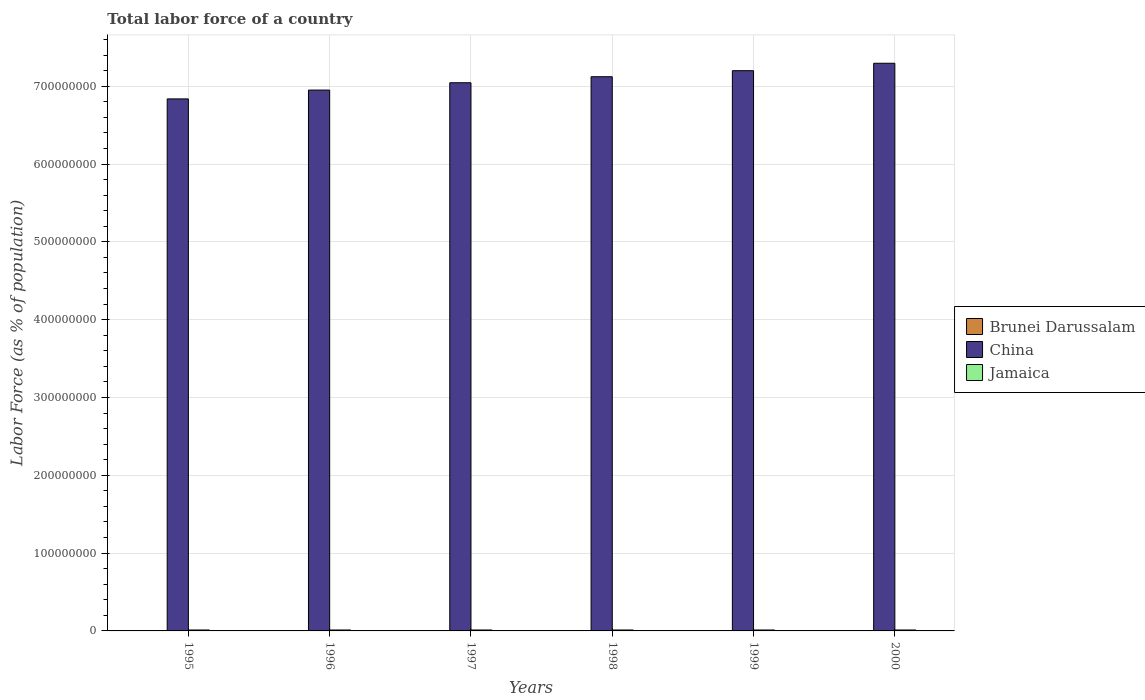How many different coloured bars are there?
Provide a succinct answer. 3. How many groups of bars are there?
Keep it short and to the point. 6. Are the number of bars per tick equal to the number of legend labels?
Give a very brief answer. Yes. What is the label of the 2nd group of bars from the left?
Make the answer very short. 1996. What is the percentage of labor force in Brunei Darussalam in 1998?
Provide a succinct answer. 1.45e+05. Across all years, what is the maximum percentage of labor force in Brunei Darussalam?
Offer a terse response. 1.55e+05. Across all years, what is the minimum percentage of labor force in Brunei Darussalam?
Offer a terse response. 1.31e+05. In which year was the percentage of labor force in Brunei Darussalam maximum?
Ensure brevity in your answer.  2000. In which year was the percentage of labor force in China minimum?
Your answer should be very brief. 1995. What is the total percentage of labor force in Jamaica in the graph?
Your response must be concise. 7.18e+06. What is the difference between the percentage of labor force in Jamaica in 1996 and that in 1997?
Your answer should be compact. 5620. What is the difference between the percentage of labor force in China in 1999 and the percentage of labor force in Brunei Darussalam in 1996?
Provide a short and direct response. 7.20e+08. What is the average percentage of labor force in Brunei Darussalam per year?
Ensure brevity in your answer.  1.43e+05. In the year 1995, what is the difference between the percentage of labor force in Jamaica and percentage of labor force in China?
Keep it short and to the point. -6.82e+08. What is the ratio of the percentage of labor force in Jamaica in 1995 to that in 1996?
Your response must be concise. 1. Is the percentage of labor force in Jamaica in 1995 less than that in 1996?
Make the answer very short. Yes. Is the difference between the percentage of labor force in Jamaica in 1997 and 2000 greater than the difference between the percentage of labor force in China in 1997 and 2000?
Offer a very short reply. Yes. What is the difference between the highest and the second highest percentage of labor force in China?
Make the answer very short. 9.53e+06. What is the difference between the highest and the lowest percentage of labor force in China?
Offer a very short reply. 4.58e+07. What does the 1st bar from the left in 1995 represents?
Provide a succinct answer. Brunei Darussalam. What does the 3rd bar from the right in 1997 represents?
Your answer should be very brief. Brunei Darussalam. How many bars are there?
Offer a very short reply. 18. What is the difference between two consecutive major ticks on the Y-axis?
Offer a very short reply. 1.00e+08. What is the title of the graph?
Give a very brief answer. Total labor force of a country. What is the label or title of the Y-axis?
Your answer should be compact. Labor Force (as % of population). What is the Labor Force (as % of population) of Brunei Darussalam in 1995?
Your answer should be compact. 1.31e+05. What is the Labor Force (as % of population) in China in 1995?
Your answer should be very brief. 6.84e+08. What is the Labor Force (as % of population) in Jamaica in 1995?
Offer a terse response. 1.20e+06. What is the Labor Force (as % of population) of Brunei Darussalam in 1996?
Provide a short and direct response. 1.36e+05. What is the Labor Force (as % of population) in China in 1996?
Provide a short and direct response. 6.95e+08. What is the Labor Force (as % of population) of Jamaica in 1996?
Provide a short and direct response. 1.20e+06. What is the Labor Force (as % of population) of Brunei Darussalam in 1997?
Give a very brief answer. 1.41e+05. What is the Labor Force (as % of population) of China in 1997?
Keep it short and to the point. 7.04e+08. What is the Labor Force (as % of population) of Jamaica in 1997?
Ensure brevity in your answer.  1.20e+06. What is the Labor Force (as % of population) in Brunei Darussalam in 1998?
Give a very brief answer. 1.45e+05. What is the Labor Force (as % of population) in China in 1998?
Keep it short and to the point. 7.12e+08. What is the Labor Force (as % of population) in Jamaica in 1998?
Offer a terse response. 1.19e+06. What is the Labor Force (as % of population) of Brunei Darussalam in 1999?
Make the answer very short. 1.51e+05. What is the Labor Force (as % of population) of China in 1999?
Offer a terse response. 7.20e+08. What is the Labor Force (as % of population) of Jamaica in 1999?
Your answer should be compact. 1.19e+06. What is the Labor Force (as % of population) in Brunei Darussalam in 2000?
Your response must be concise. 1.55e+05. What is the Labor Force (as % of population) of China in 2000?
Provide a succinct answer. 7.29e+08. What is the Labor Force (as % of population) in Jamaica in 2000?
Make the answer very short. 1.19e+06. Across all years, what is the maximum Labor Force (as % of population) of Brunei Darussalam?
Provide a short and direct response. 1.55e+05. Across all years, what is the maximum Labor Force (as % of population) in China?
Your response must be concise. 7.29e+08. Across all years, what is the maximum Labor Force (as % of population) of Jamaica?
Offer a very short reply. 1.20e+06. Across all years, what is the minimum Labor Force (as % of population) of Brunei Darussalam?
Offer a terse response. 1.31e+05. Across all years, what is the minimum Labor Force (as % of population) of China?
Provide a short and direct response. 6.84e+08. Across all years, what is the minimum Labor Force (as % of population) of Jamaica?
Make the answer very short. 1.19e+06. What is the total Labor Force (as % of population) in Brunei Darussalam in the graph?
Ensure brevity in your answer.  8.59e+05. What is the total Labor Force (as % of population) in China in the graph?
Ensure brevity in your answer.  4.24e+09. What is the total Labor Force (as % of population) in Jamaica in the graph?
Keep it short and to the point. 7.18e+06. What is the difference between the Labor Force (as % of population) in Brunei Darussalam in 1995 and that in 1996?
Your answer should be compact. -4586. What is the difference between the Labor Force (as % of population) in China in 1995 and that in 1996?
Give a very brief answer. -1.13e+07. What is the difference between the Labor Force (as % of population) of Jamaica in 1995 and that in 1996?
Make the answer very short. -999. What is the difference between the Labor Force (as % of population) of Brunei Darussalam in 1995 and that in 1997?
Offer a terse response. -9384. What is the difference between the Labor Force (as % of population) of China in 1995 and that in 1997?
Provide a succinct answer. -2.08e+07. What is the difference between the Labor Force (as % of population) of Jamaica in 1995 and that in 1997?
Ensure brevity in your answer.  4621. What is the difference between the Labor Force (as % of population) in Brunei Darussalam in 1995 and that in 1998?
Keep it short and to the point. -1.43e+04. What is the difference between the Labor Force (as % of population) of China in 1995 and that in 1998?
Make the answer very short. -2.85e+07. What is the difference between the Labor Force (as % of population) in Jamaica in 1995 and that in 1998?
Keep it short and to the point. 1.14e+04. What is the difference between the Labor Force (as % of population) in Brunei Darussalam in 1995 and that in 1999?
Your response must be concise. -1.94e+04. What is the difference between the Labor Force (as % of population) of China in 1995 and that in 1999?
Ensure brevity in your answer.  -3.63e+07. What is the difference between the Labor Force (as % of population) in Jamaica in 1995 and that in 1999?
Ensure brevity in your answer.  8970. What is the difference between the Labor Force (as % of population) of Brunei Darussalam in 1995 and that in 2000?
Ensure brevity in your answer.  -2.44e+04. What is the difference between the Labor Force (as % of population) in China in 1995 and that in 2000?
Provide a short and direct response. -4.58e+07. What is the difference between the Labor Force (as % of population) of Jamaica in 1995 and that in 2000?
Give a very brief answer. 7658. What is the difference between the Labor Force (as % of population) of Brunei Darussalam in 1996 and that in 1997?
Your answer should be very brief. -4798. What is the difference between the Labor Force (as % of population) of China in 1996 and that in 1997?
Offer a very short reply. -9.41e+06. What is the difference between the Labor Force (as % of population) in Jamaica in 1996 and that in 1997?
Keep it short and to the point. 5620. What is the difference between the Labor Force (as % of population) of Brunei Darussalam in 1996 and that in 1998?
Your answer should be very brief. -9750. What is the difference between the Labor Force (as % of population) of China in 1996 and that in 1998?
Ensure brevity in your answer.  -1.71e+07. What is the difference between the Labor Force (as % of population) in Jamaica in 1996 and that in 1998?
Your answer should be compact. 1.24e+04. What is the difference between the Labor Force (as % of population) of Brunei Darussalam in 1996 and that in 1999?
Offer a very short reply. -1.48e+04. What is the difference between the Labor Force (as % of population) in China in 1996 and that in 1999?
Provide a succinct answer. -2.49e+07. What is the difference between the Labor Force (as % of population) of Jamaica in 1996 and that in 1999?
Your response must be concise. 9969. What is the difference between the Labor Force (as % of population) of Brunei Darussalam in 1996 and that in 2000?
Your response must be concise. -1.98e+04. What is the difference between the Labor Force (as % of population) in China in 1996 and that in 2000?
Make the answer very short. -3.45e+07. What is the difference between the Labor Force (as % of population) in Jamaica in 1996 and that in 2000?
Keep it short and to the point. 8657. What is the difference between the Labor Force (as % of population) in Brunei Darussalam in 1997 and that in 1998?
Give a very brief answer. -4952. What is the difference between the Labor Force (as % of population) of China in 1997 and that in 1998?
Your response must be concise. -7.73e+06. What is the difference between the Labor Force (as % of population) in Jamaica in 1997 and that in 1998?
Offer a terse response. 6774. What is the difference between the Labor Force (as % of population) in Brunei Darussalam in 1997 and that in 1999?
Offer a terse response. -1.00e+04. What is the difference between the Labor Force (as % of population) in China in 1997 and that in 1999?
Keep it short and to the point. -1.55e+07. What is the difference between the Labor Force (as % of population) of Jamaica in 1997 and that in 1999?
Provide a succinct answer. 4349. What is the difference between the Labor Force (as % of population) in Brunei Darussalam in 1997 and that in 2000?
Give a very brief answer. -1.50e+04. What is the difference between the Labor Force (as % of population) of China in 1997 and that in 2000?
Offer a very short reply. -2.50e+07. What is the difference between the Labor Force (as % of population) of Jamaica in 1997 and that in 2000?
Keep it short and to the point. 3037. What is the difference between the Labor Force (as % of population) in Brunei Darussalam in 1998 and that in 1999?
Provide a succinct answer. -5076. What is the difference between the Labor Force (as % of population) in China in 1998 and that in 1999?
Give a very brief answer. -7.78e+06. What is the difference between the Labor Force (as % of population) of Jamaica in 1998 and that in 1999?
Give a very brief answer. -2425. What is the difference between the Labor Force (as % of population) in Brunei Darussalam in 1998 and that in 2000?
Give a very brief answer. -1.00e+04. What is the difference between the Labor Force (as % of population) in China in 1998 and that in 2000?
Your answer should be compact. -1.73e+07. What is the difference between the Labor Force (as % of population) of Jamaica in 1998 and that in 2000?
Offer a terse response. -3737. What is the difference between the Labor Force (as % of population) of Brunei Darussalam in 1999 and that in 2000?
Keep it short and to the point. -4948. What is the difference between the Labor Force (as % of population) of China in 1999 and that in 2000?
Provide a short and direct response. -9.53e+06. What is the difference between the Labor Force (as % of population) of Jamaica in 1999 and that in 2000?
Provide a succinct answer. -1312. What is the difference between the Labor Force (as % of population) in Brunei Darussalam in 1995 and the Labor Force (as % of population) in China in 1996?
Your answer should be compact. -6.95e+08. What is the difference between the Labor Force (as % of population) in Brunei Darussalam in 1995 and the Labor Force (as % of population) in Jamaica in 1996?
Your response must be concise. -1.07e+06. What is the difference between the Labor Force (as % of population) in China in 1995 and the Labor Force (as % of population) in Jamaica in 1996?
Your response must be concise. 6.82e+08. What is the difference between the Labor Force (as % of population) of Brunei Darussalam in 1995 and the Labor Force (as % of population) of China in 1997?
Your response must be concise. -7.04e+08. What is the difference between the Labor Force (as % of population) in Brunei Darussalam in 1995 and the Labor Force (as % of population) in Jamaica in 1997?
Your answer should be very brief. -1.07e+06. What is the difference between the Labor Force (as % of population) of China in 1995 and the Labor Force (as % of population) of Jamaica in 1997?
Provide a succinct answer. 6.82e+08. What is the difference between the Labor Force (as % of population) in Brunei Darussalam in 1995 and the Labor Force (as % of population) in China in 1998?
Provide a short and direct response. -7.12e+08. What is the difference between the Labor Force (as % of population) of Brunei Darussalam in 1995 and the Labor Force (as % of population) of Jamaica in 1998?
Ensure brevity in your answer.  -1.06e+06. What is the difference between the Labor Force (as % of population) in China in 1995 and the Labor Force (as % of population) in Jamaica in 1998?
Your answer should be compact. 6.82e+08. What is the difference between the Labor Force (as % of population) in Brunei Darussalam in 1995 and the Labor Force (as % of population) in China in 1999?
Offer a terse response. -7.20e+08. What is the difference between the Labor Force (as % of population) of Brunei Darussalam in 1995 and the Labor Force (as % of population) of Jamaica in 1999?
Give a very brief answer. -1.06e+06. What is the difference between the Labor Force (as % of population) of China in 1995 and the Labor Force (as % of population) of Jamaica in 1999?
Ensure brevity in your answer.  6.82e+08. What is the difference between the Labor Force (as % of population) in Brunei Darussalam in 1995 and the Labor Force (as % of population) in China in 2000?
Keep it short and to the point. -7.29e+08. What is the difference between the Labor Force (as % of population) of Brunei Darussalam in 1995 and the Labor Force (as % of population) of Jamaica in 2000?
Your answer should be very brief. -1.06e+06. What is the difference between the Labor Force (as % of population) of China in 1995 and the Labor Force (as % of population) of Jamaica in 2000?
Offer a very short reply. 6.82e+08. What is the difference between the Labor Force (as % of population) of Brunei Darussalam in 1996 and the Labor Force (as % of population) of China in 1997?
Your answer should be very brief. -7.04e+08. What is the difference between the Labor Force (as % of population) in Brunei Darussalam in 1996 and the Labor Force (as % of population) in Jamaica in 1997?
Provide a succinct answer. -1.06e+06. What is the difference between the Labor Force (as % of population) in China in 1996 and the Labor Force (as % of population) in Jamaica in 1997?
Provide a succinct answer. 6.94e+08. What is the difference between the Labor Force (as % of population) of Brunei Darussalam in 1996 and the Labor Force (as % of population) of China in 1998?
Give a very brief answer. -7.12e+08. What is the difference between the Labor Force (as % of population) of Brunei Darussalam in 1996 and the Labor Force (as % of population) of Jamaica in 1998?
Offer a very short reply. -1.05e+06. What is the difference between the Labor Force (as % of population) in China in 1996 and the Labor Force (as % of population) in Jamaica in 1998?
Ensure brevity in your answer.  6.94e+08. What is the difference between the Labor Force (as % of population) of Brunei Darussalam in 1996 and the Labor Force (as % of population) of China in 1999?
Offer a very short reply. -7.20e+08. What is the difference between the Labor Force (as % of population) in Brunei Darussalam in 1996 and the Labor Force (as % of population) in Jamaica in 1999?
Keep it short and to the point. -1.06e+06. What is the difference between the Labor Force (as % of population) of China in 1996 and the Labor Force (as % of population) of Jamaica in 1999?
Give a very brief answer. 6.94e+08. What is the difference between the Labor Force (as % of population) in Brunei Darussalam in 1996 and the Labor Force (as % of population) in China in 2000?
Ensure brevity in your answer.  -7.29e+08. What is the difference between the Labor Force (as % of population) in Brunei Darussalam in 1996 and the Labor Force (as % of population) in Jamaica in 2000?
Keep it short and to the point. -1.06e+06. What is the difference between the Labor Force (as % of population) of China in 1996 and the Labor Force (as % of population) of Jamaica in 2000?
Ensure brevity in your answer.  6.94e+08. What is the difference between the Labor Force (as % of population) of Brunei Darussalam in 1997 and the Labor Force (as % of population) of China in 1998?
Keep it short and to the point. -7.12e+08. What is the difference between the Labor Force (as % of population) of Brunei Darussalam in 1997 and the Labor Force (as % of population) of Jamaica in 1998?
Your answer should be very brief. -1.05e+06. What is the difference between the Labor Force (as % of population) in China in 1997 and the Labor Force (as % of population) in Jamaica in 1998?
Offer a terse response. 7.03e+08. What is the difference between the Labor Force (as % of population) in Brunei Darussalam in 1997 and the Labor Force (as % of population) in China in 1999?
Provide a short and direct response. -7.20e+08. What is the difference between the Labor Force (as % of population) in Brunei Darussalam in 1997 and the Labor Force (as % of population) in Jamaica in 1999?
Provide a short and direct response. -1.05e+06. What is the difference between the Labor Force (as % of population) in China in 1997 and the Labor Force (as % of population) in Jamaica in 1999?
Give a very brief answer. 7.03e+08. What is the difference between the Labor Force (as % of population) in Brunei Darussalam in 1997 and the Labor Force (as % of population) in China in 2000?
Ensure brevity in your answer.  -7.29e+08. What is the difference between the Labor Force (as % of population) of Brunei Darussalam in 1997 and the Labor Force (as % of population) of Jamaica in 2000?
Provide a short and direct response. -1.05e+06. What is the difference between the Labor Force (as % of population) in China in 1997 and the Labor Force (as % of population) in Jamaica in 2000?
Your response must be concise. 7.03e+08. What is the difference between the Labor Force (as % of population) in Brunei Darussalam in 1998 and the Labor Force (as % of population) in China in 1999?
Your answer should be compact. -7.20e+08. What is the difference between the Labor Force (as % of population) of Brunei Darussalam in 1998 and the Labor Force (as % of population) of Jamaica in 1999?
Provide a short and direct response. -1.05e+06. What is the difference between the Labor Force (as % of population) of China in 1998 and the Labor Force (as % of population) of Jamaica in 1999?
Give a very brief answer. 7.11e+08. What is the difference between the Labor Force (as % of population) in Brunei Darussalam in 1998 and the Labor Force (as % of population) in China in 2000?
Provide a short and direct response. -7.29e+08. What is the difference between the Labor Force (as % of population) of Brunei Darussalam in 1998 and the Labor Force (as % of population) of Jamaica in 2000?
Offer a terse response. -1.05e+06. What is the difference between the Labor Force (as % of population) of China in 1998 and the Labor Force (as % of population) of Jamaica in 2000?
Give a very brief answer. 7.11e+08. What is the difference between the Labor Force (as % of population) in Brunei Darussalam in 1999 and the Labor Force (as % of population) in China in 2000?
Provide a short and direct response. -7.29e+08. What is the difference between the Labor Force (as % of population) in Brunei Darussalam in 1999 and the Labor Force (as % of population) in Jamaica in 2000?
Offer a very short reply. -1.04e+06. What is the difference between the Labor Force (as % of population) in China in 1999 and the Labor Force (as % of population) in Jamaica in 2000?
Offer a very short reply. 7.19e+08. What is the average Labor Force (as % of population) of Brunei Darussalam per year?
Your answer should be very brief. 1.43e+05. What is the average Labor Force (as % of population) in China per year?
Your answer should be very brief. 7.07e+08. What is the average Labor Force (as % of population) of Jamaica per year?
Your response must be concise. 1.20e+06. In the year 1995, what is the difference between the Labor Force (as % of population) in Brunei Darussalam and Labor Force (as % of population) in China?
Provide a succinct answer. -6.84e+08. In the year 1995, what is the difference between the Labor Force (as % of population) in Brunei Darussalam and Labor Force (as % of population) in Jamaica?
Provide a succinct answer. -1.07e+06. In the year 1995, what is the difference between the Labor Force (as % of population) in China and Labor Force (as % of population) in Jamaica?
Make the answer very short. 6.82e+08. In the year 1996, what is the difference between the Labor Force (as % of population) in Brunei Darussalam and Labor Force (as % of population) in China?
Give a very brief answer. -6.95e+08. In the year 1996, what is the difference between the Labor Force (as % of population) of Brunei Darussalam and Labor Force (as % of population) of Jamaica?
Keep it short and to the point. -1.07e+06. In the year 1996, what is the difference between the Labor Force (as % of population) in China and Labor Force (as % of population) in Jamaica?
Provide a succinct answer. 6.94e+08. In the year 1997, what is the difference between the Labor Force (as % of population) in Brunei Darussalam and Labor Force (as % of population) in China?
Offer a very short reply. -7.04e+08. In the year 1997, what is the difference between the Labor Force (as % of population) of Brunei Darussalam and Labor Force (as % of population) of Jamaica?
Keep it short and to the point. -1.06e+06. In the year 1997, what is the difference between the Labor Force (as % of population) of China and Labor Force (as % of population) of Jamaica?
Your answer should be compact. 7.03e+08. In the year 1998, what is the difference between the Labor Force (as % of population) of Brunei Darussalam and Labor Force (as % of population) of China?
Your answer should be very brief. -7.12e+08. In the year 1998, what is the difference between the Labor Force (as % of population) in Brunei Darussalam and Labor Force (as % of population) in Jamaica?
Provide a succinct answer. -1.04e+06. In the year 1998, what is the difference between the Labor Force (as % of population) in China and Labor Force (as % of population) in Jamaica?
Ensure brevity in your answer.  7.11e+08. In the year 1999, what is the difference between the Labor Force (as % of population) of Brunei Darussalam and Labor Force (as % of population) of China?
Keep it short and to the point. -7.20e+08. In the year 1999, what is the difference between the Labor Force (as % of population) of Brunei Darussalam and Labor Force (as % of population) of Jamaica?
Your answer should be compact. -1.04e+06. In the year 1999, what is the difference between the Labor Force (as % of population) in China and Labor Force (as % of population) in Jamaica?
Offer a terse response. 7.19e+08. In the year 2000, what is the difference between the Labor Force (as % of population) in Brunei Darussalam and Labor Force (as % of population) in China?
Provide a succinct answer. -7.29e+08. In the year 2000, what is the difference between the Labor Force (as % of population) of Brunei Darussalam and Labor Force (as % of population) of Jamaica?
Give a very brief answer. -1.04e+06. In the year 2000, what is the difference between the Labor Force (as % of population) of China and Labor Force (as % of population) of Jamaica?
Ensure brevity in your answer.  7.28e+08. What is the ratio of the Labor Force (as % of population) of Brunei Darussalam in 1995 to that in 1996?
Your answer should be compact. 0.97. What is the ratio of the Labor Force (as % of population) in China in 1995 to that in 1996?
Your answer should be compact. 0.98. What is the ratio of the Labor Force (as % of population) of Jamaica in 1995 to that in 1996?
Your answer should be compact. 1. What is the ratio of the Labor Force (as % of population) of Brunei Darussalam in 1995 to that in 1997?
Your response must be concise. 0.93. What is the ratio of the Labor Force (as % of population) in China in 1995 to that in 1997?
Your response must be concise. 0.97. What is the ratio of the Labor Force (as % of population) in Brunei Darussalam in 1995 to that in 1998?
Make the answer very short. 0.9. What is the ratio of the Labor Force (as % of population) of Jamaica in 1995 to that in 1998?
Offer a very short reply. 1.01. What is the ratio of the Labor Force (as % of population) in Brunei Darussalam in 1995 to that in 1999?
Keep it short and to the point. 0.87. What is the ratio of the Labor Force (as % of population) of China in 1995 to that in 1999?
Your answer should be compact. 0.95. What is the ratio of the Labor Force (as % of population) of Jamaica in 1995 to that in 1999?
Your response must be concise. 1.01. What is the ratio of the Labor Force (as % of population) of Brunei Darussalam in 1995 to that in 2000?
Your answer should be very brief. 0.84. What is the ratio of the Labor Force (as % of population) in China in 1995 to that in 2000?
Provide a succinct answer. 0.94. What is the ratio of the Labor Force (as % of population) in Jamaica in 1995 to that in 2000?
Your response must be concise. 1.01. What is the ratio of the Labor Force (as % of population) of Brunei Darussalam in 1996 to that in 1997?
Provide a succinct answer. 0.97. What is the ratio of the Labor Force (as % of population) of China in 1996 to that in 1997?
Ensure brevity in your answer.  0.99. What is the ratio of the Labor Force (as % of population) of Brunei Darussalam in 1996 to that in 1998?
Give a very brief answer. 0.93. What is the ratio of the Labor Force (as % of population) in China in 1996 to that in 1998?
Your answer should be compact. 0.98. What is the ratio of the Labor Force (as % of population) of Jamaica in 1996 to that in 1998?
Make the answer very short. 1.01. What is the ratio of the Labor Force (as % of population) of Brunei Darussalam in 1996 to that in 1999?
Provide a short and direct response. 0.9. What is the ratio of the Labor Force (as % of population) in China in 1996 to that in 1999?
Keep it short and to the point. 0.97. What is the ratio of the Labor Force (as % of population) in Jamaica in 1996 to that in 1999?
Your response must be concise. 1.01. What is the ratio of the Labor Force (as % of population) in Brunei Darussalam in 1996 to that in 2000?
Your answer should be very brief. 0.87. What is the ratio of the Labor Force (as % of population) in China in 1996 to that in 2000?
Provide a short and direct response. 0.95. What is the ratio of the Labor Force (as % of population) of Jamaica in 1996 to that in 2000?
Provide a succinct answer. 1.01. What is the ratio of the Labor Force (as % of population) in Brunei Darussalam in 1997 to that in 1998?
Provide a short and direct response. 0.97. What is the ratio of the Labor Force (as % of population) in Jamaica in 1997 to that in 1998?
Keep it short and to the point. 1.01. What is the ratio of the Labor Force (as % of population) of Brunei Darussalam in 1997 to that in 1999?
Your answer should be very brief. 0.93. What is the ratio of the Labor Force (as % of population) of China in 1997 to that in 1999?
Offer a terse response. 0.98. What is the ratio of the Labor Force (as % of population) in Brunei Darussalam in 1997 to that in 2000?
Your response must be concise. 0.9. What is the ratio of the Labor Force (as % of population) in China in 1997 to that in 2000?
Ensure brevity in your answer.  0.97. What is the ratio of the Labor Force (as % of population) of Jamaica in 1997 to that in 2000?
Offer a terse response. 1. What is the ratio of the Labor Force (as % of population) in Brunei Darussalam in 1998 to that in 1999?
Your response must be concise. 0.97. What is the ratio of the Labor Force (as % of population) of China in 1998 to that in 1999?
Offer a very short reply. 0.99. What is the ratio of the Labor Force (as % of population) in Jamaica in 1998 to that in 1999?
Ensure brevity in your answer.  1. What is the ratio of the Labor Force (as % of population) in Brunei Darussalam in 1998 to that in 2000?
Your response must be concise. 0.94. What is the ratio of the Labor Force (as % of population) in China in 1998 to that in 2000?
Your response must be concise. 0.98. What is the ratio of the Labor Force (as % of population) of Brunei Darussalam in 1999 to that in 2000?
Provide a short and direct response. 0.97. What is the ratio of the Labor Force (as % of population) of China in 1999 to that in 2000?
Ensure brevity in your answer.  0.99. What is the difference between the highest and the second highest Labor Force (as % of population) of Brunei Darussalam?
Ensure brevity in your answer.  4948. What is the difference between the highest and the second highest Labor Force (as % of population) in China?
Your response must be concise. 9.53e+06. What is the difference between the highest and the second highest Labor Force (as % of population) in Jamaica?
Provide a short and direct response. 999. What is the difference between the highest and the lowest Labor Force (as % of population) in Brunei Darussalam?
Give a very brief answer. 2.44e+04. What is the difference between the highest and the lowest Labor Force (as % of population) in China?
Your response must be concise. 4.58e+07. What is the difference between the highest and the lowest Labor Force (as % of population) in Jamaica?
Offer a terse response. 1.24e+04. 